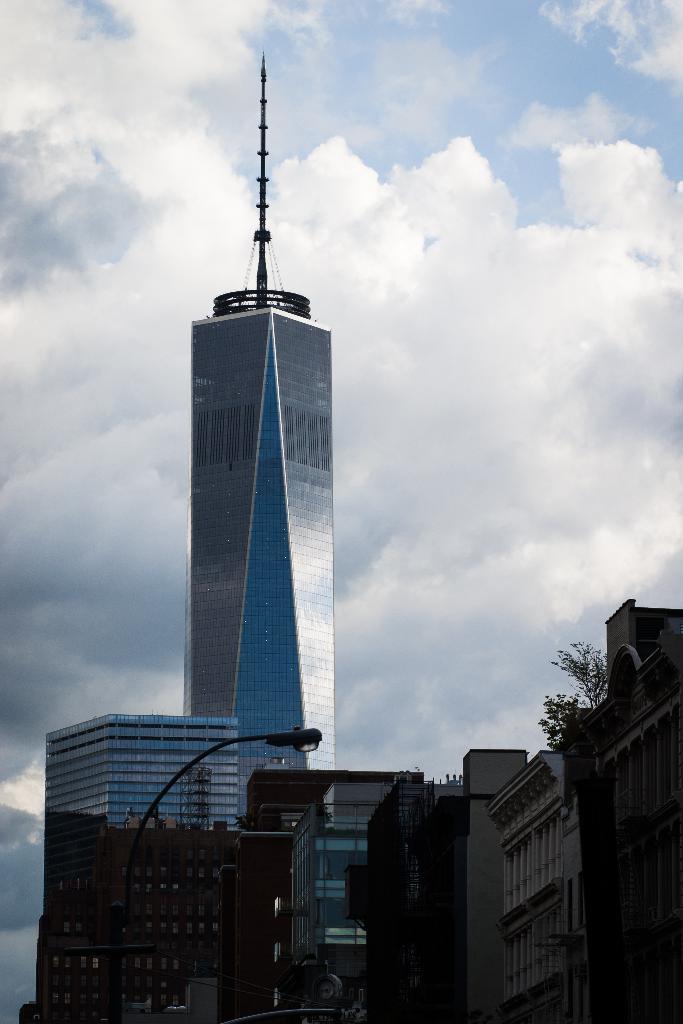Can you describe this image briefly? In this picture we can see a tower, buildings, here we can see a street light, trees and some objects and we can see sky in the background. 